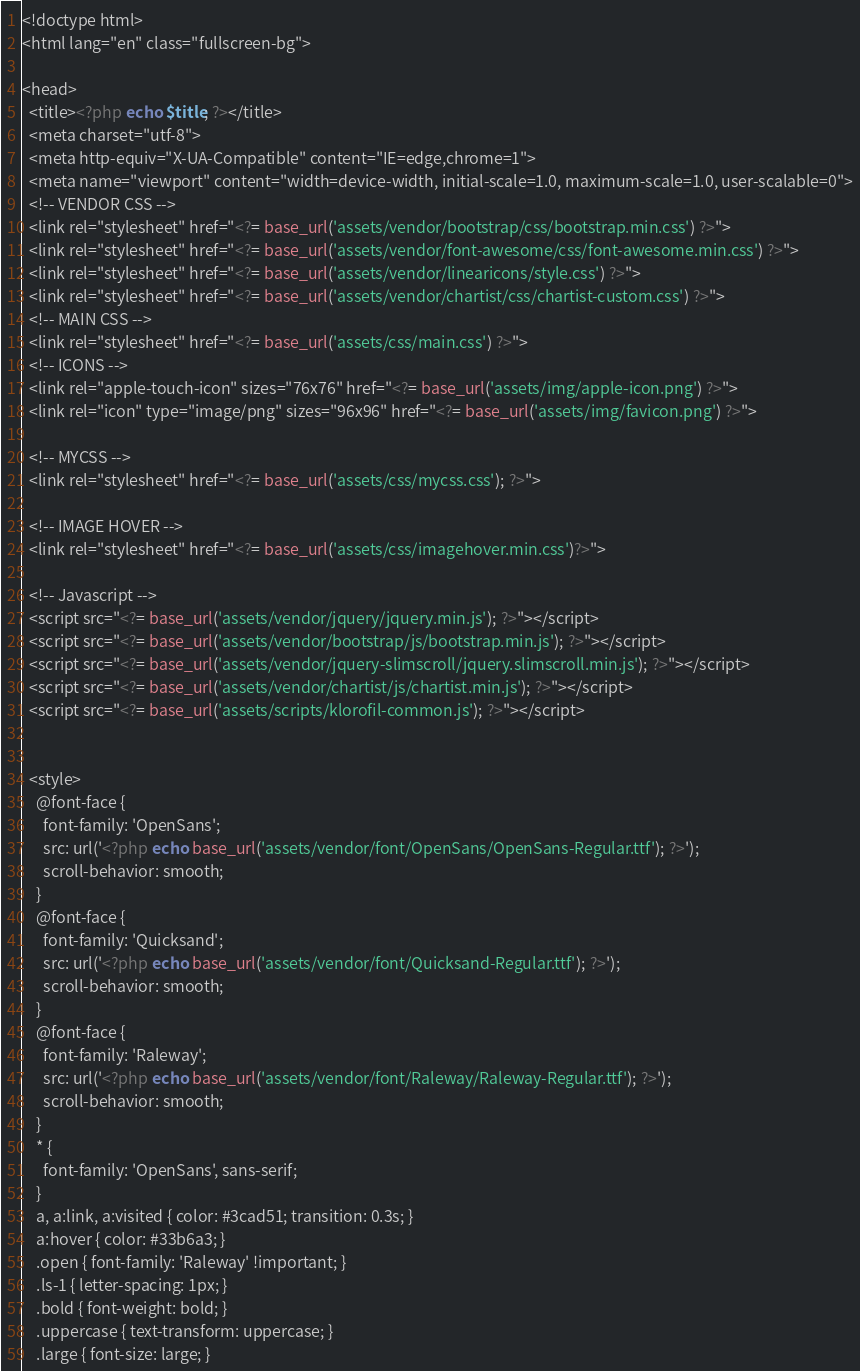Convert code to text. <code><loc_0><loc_0><loc_500><loc_500><_PHP_><!doctype html>
<html lang="en" class="fullscreen-bg">

<head>
  <title><?php echo $title; ?></title>
  <meta charset="utf-8">
  <meta http-equiv="X-UA-Compatible" content="IE=edge,chrome=1">
  <meta name="viewport" content="width=device-width, initial-scale=1.0, maximum-scale=1.0, user-scalable=0">
  <!-- VENDOR CSS -->
  <link rel="stylesheet" href="<?= base_url('assets/vendor/bootstrap/css/bootstrap.min.css') ?>">
  <link rel="stylesheet" href="<?= base_url('assets/vendor/font-awesome/css/font-awesome.min.css') ?>">
  <link rel="stylesheet" href="<?= base_url('assets/vendor/linearicons/style.css') ?>">
  <link rel="stylesheet" href="<?= base_url('assets/vendor/chartist/css/chartist-custom.css') ?>">
  <!-- MAIN CSS -->
  <link rel="stylesheet" href="<?= base_url('assets/css/main.css') ?>">
  <!-- ICONS -->
  <link rel="apple-touch-icon" sizes="76x76" href="<?= base_url('assets/img/apple-icon.png') ?>">
  <link rel="icon" type="image/png" sizes="96x96" href="<?= base_url('assets/img/favicon.png') ?>">

  <!-- MYCSS -->
  <link rel="stylesheet" href="<?= base_url('assets/css/mycss.css'); ?>">

  <!-- IMAGE HOVER -->
  <link rel="stylesheet" href="<?= base_url('assets/css/imagehover.min.css')?>">

  <!-- Javascript -->
  <script src="<?= base_url('assets/vendor/jquery/jquery.min.js'); ?>"></script>
  <script src="<?= base_url('assets/vendor/bootstrap/js/bootstrap.min.js'); ?>"></script>
  <script src="<?= base_url('assets/vendor/jquery-slimscroll/jquery.slimscroll.min.js'); ?>"></script>
  <script src="<?= base_url('assets/vendor/chartist/js/chartist.min.js'); ?>"></script>
  <script src="<?= base_url('assets/scripts/klorofil-common.js'); ?>"></script>


  <style>
    @font-face {
      font-family: 'OpenSans';
      src: url('<?php echo base_url('assets/vendor/font/OpenSans/OpenSans-Regular.ttf'); ?>');
      scroll-behavior: smooth;
    }
    @font-face {
      font-family: 'Quicksand';
      src: url('<?php echo base_url('assets/vendor/font/Quicksand-Regular.ttf'); ?>');
      scroll-behavior: smooth;
    }
    @font-face {
      font-family: 'Raleway';
      src: url('<?php echo base_url('assets/vendor/font/Raleway/Raleway-Regular.ttf'); ?>');
      scroll-behavior: smooth;
    }
    * {
      font-family: 'OpenSans', sans-serif;
    }
    a, a:link, a:visited { color: #3cad51; transition: 0.3s; }
    a:hover { color: #33b6a3; }
    .open { font-family: 'Raleway' !important; }
    .ls-1 { letter-spacing: 1px; }
    .bold { font-weight: bold; }
    .uppercase { text-transform: uppercase; }
    .large { font-size: large; }</code> 